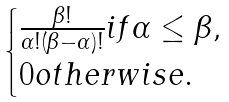<formula> <loc_0><loc_0><loc_500><loc_500>\begin{cases} \frac { \beta ! } { \alpha ! ( \beta - \alpha ) ! } i f \alpha \leq \beta , \\ 0 o t h e r w i s e . \end{cases}</formula> 